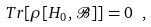Convert formula to latex. <formula><loc_0><loc_0><loc_500><loc_500>T r [ \rho [ H _ { 0 } , \mathcal { B } ] ] = 0 \ ,</formula> 